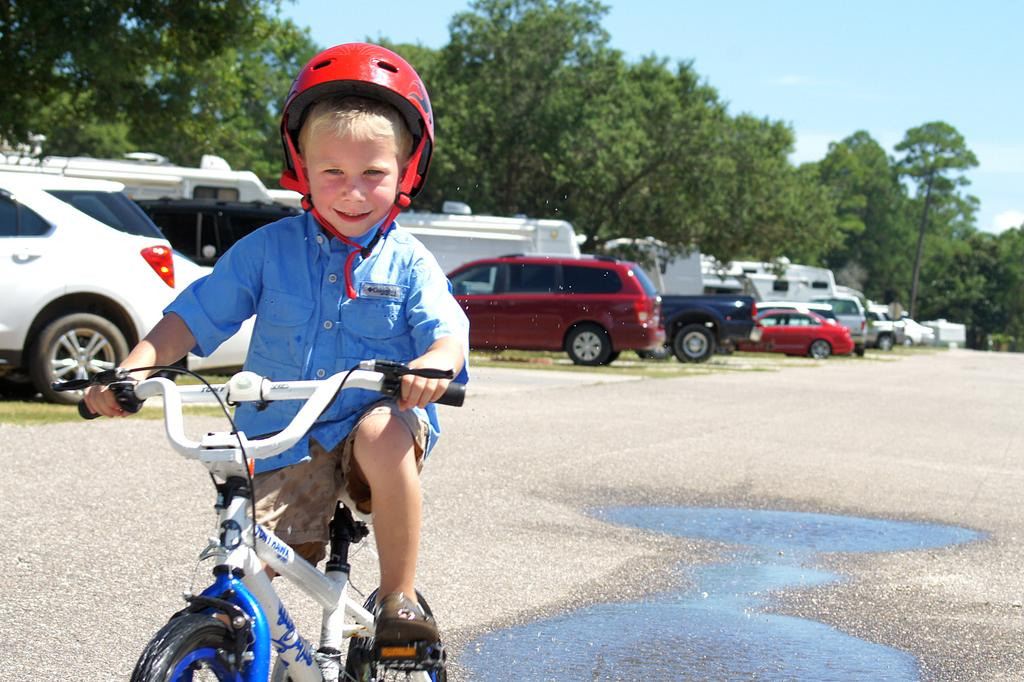What is the main subject of the image? The main subject of the image is a kid. What is the kid wearing? The kid is wearing a blue shirt. What is the kid doing in the image? The kid is riding a white bicycle. Where is the kid located? The kid is on a road. What can be seen behind the kid? There are trees and cars behind the kid. What type of poison is the kid using to ride the bicycle? There is no mention of poison in the image, and the kid is riding a bicycle without any assistance. 